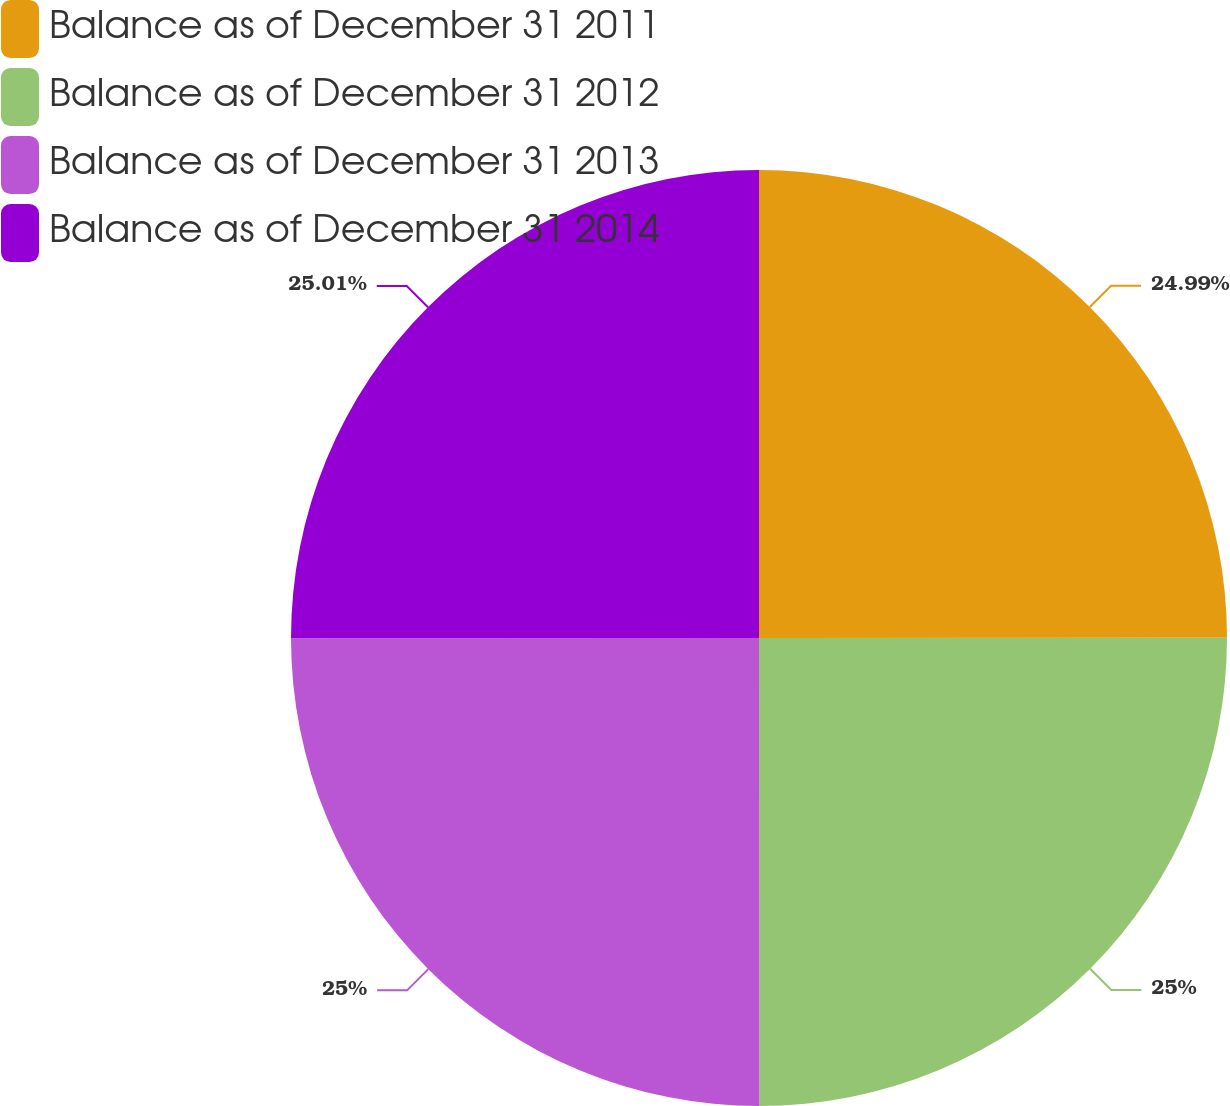Convert chart to OTSL. <chart><loc_0><loc_0><loc_500><loc_500><pie_chart><fcel>Balance as of December 31 2011<fcel>Balance as of December 31 2012<fcel>Balance as of December 31 2013<fcel>Balance as of December 31 2014<nl><fcel>24.99%<fcel>25.0%<fcel>25.0%<fcel>25.01%<nl></chart> 